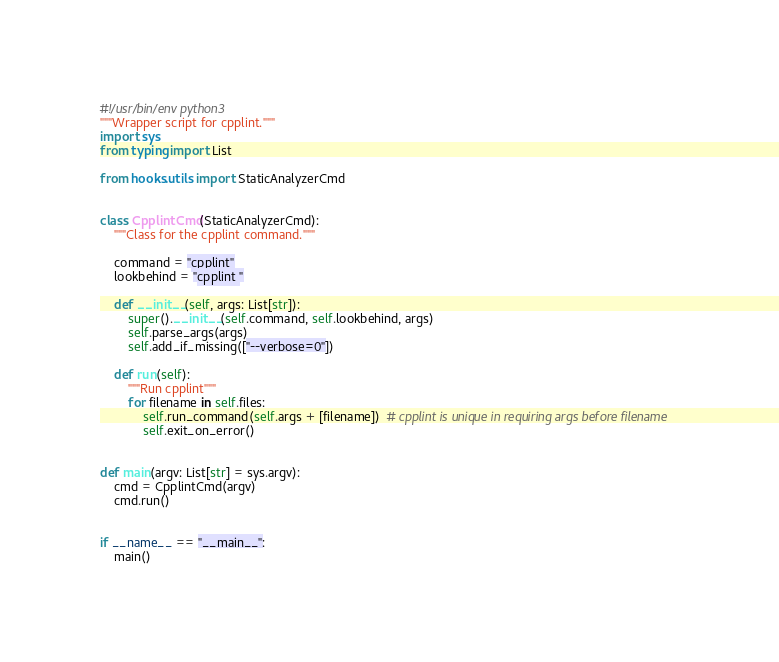<code> <loc_0><loc_0><loc_500><loc_500><_Python_>#!/usr/bin/env python3
"""Wrapper script for cpplint."""
import sys
from typing import List

from hooks.utils import StaticAnalyzerCmd


class CpplintCmd(StaticAnalyzerCmd):
    """Class for the cpplint command."""

    command = "cpplint"
    lookbehind = "cpplint "

    def __init__(self, args: List[str]):
        super().__init__(self.command, self.lookbehind, args)
        self.parse_args(args)
        self.add_if_missing(["--verbose=0"])

    def run(self):
        """Run cpplint"""
        for filename in self.files:
            self.run_command(self.args + [filename])  # cpplint is unique in requiring args before filename
            self.exit_on_error()


def main(argv: List[str] = sys.argv):
    cmd = CpplintCmd(argv)
    cmd.run()


if __name__ == "__main__":
    main()
</code> 